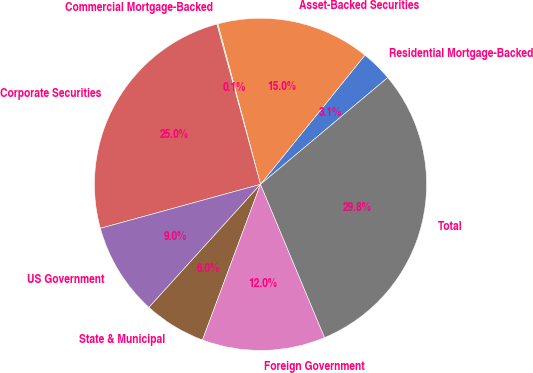<chart> <loc_0><loc_0><loc_500><loc_500><pie_chart><fcel>Residential Mortgage-Backed<fcel>Asset-Backed Securities<fcel>Commercial Mortgage-Backed<fcel>Corporate Securities<fcel>US Government<fcel>State & Municipal<fcel>Foreign Government<fcel>Total<nl><fcel>3.07%<fcel>14.95%<fcel>0.1%<fcel>25.03%<fcel>9.01%<fcel>6.04%<fcel>11.98%<fcel>29.81%<nl></chart> 